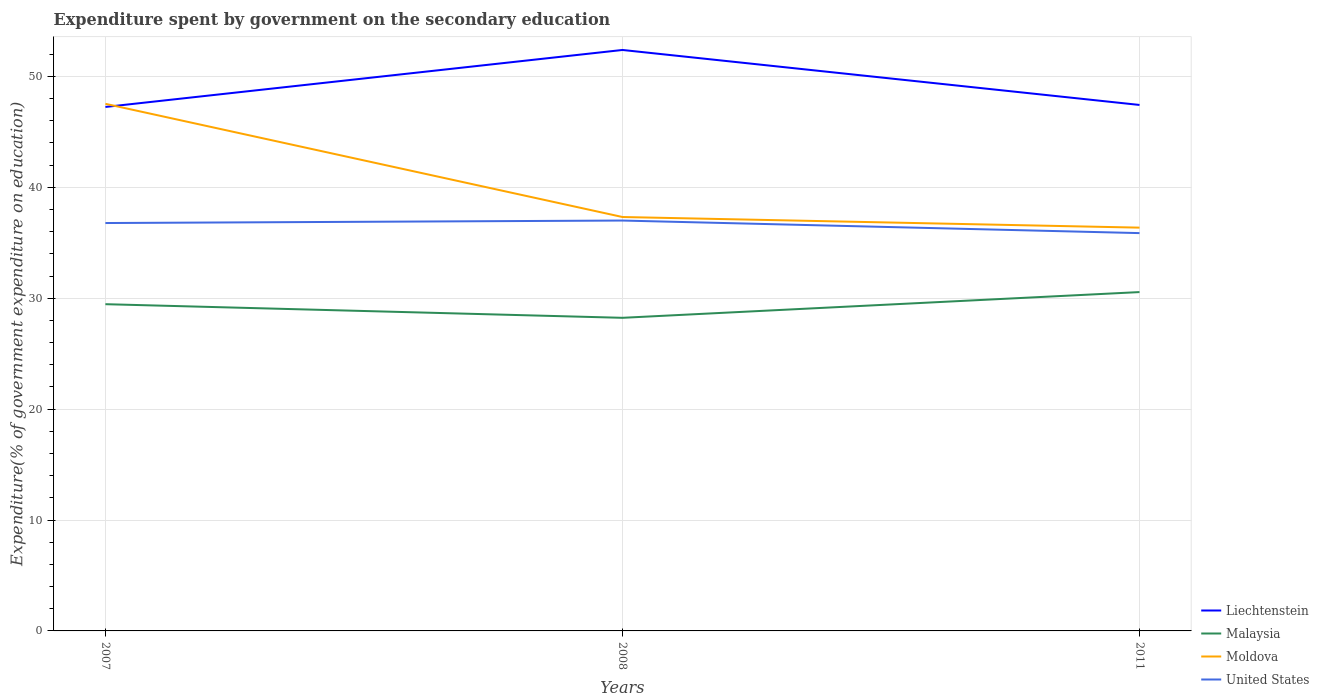Is the number of lines equal to the number of legend labels?
Your answer should be compact. Yes. Across all years, what is the maximum expenditure spent by government on the secondary education in Liechtenstein?
Give a very brief answer. 47.25. What is the total expenditure spent by government on the secondary education in Moldova in the graph?
Give a very brief answer. 10.21. What is the difference between the highest and the second highest expenditure spent by government on the secondary education in Liechtenstein?
Your answer should be very brief. 5.14. Are the values on the major ticks of Y-axis written in scientific E-notation?
Ensure brevity in your answer.  No. Does the graph contain any zero values?
Offer a very short reply. No. Does the graph contain grids?
Offer a very short reply. Yes. How are the legend labels stacked?
Offer a very short reply. Vertical. What is the title of the graph?
Provide a succinct answer. Expenditure spent by government on the secondary education. What is the label or title of the X-axis?
Offer a very short reply. Years. What is the label or title of the Y-axis?
Ensure brevity in your answer.  Expenditure(% of government expenditure on education). What is the Expenditure(% of government expenditure on education) in Liechtenstein in 2007?
Offer a terse response. 47.25. What is the Expenditure(% of government expenditure on education) of Malaysia in 2007?
Your response must be concise. 29.46. What is the Expenditure(% of government expenditure on education) of Moldova in 2007?
Your answer should be very brief. 47.53. What is the Expenditure(% of government expenditure on education) of United States in 2007?
Offer a terse response. 36.78. What is the Expenditure(% of government expenditure on education) of Liechtenstein in 2008?
Your answer should be very brief. 52.39. What is the Expenditure(% of government expenditure on education) in Malaysia in 2008?
Offer a terse response. 28.23. What is the Expenditure(% of government expenditure on education) of Moldova in 2008?
Keep it short and to the point. 37.32. What is the Expenditure(% of government expenditure on education) of United States in 2008?
Make the answer very short. 37. What is the Expenditure(% of government expenditure on education) in Liechtenstein in 2011?
Provide a succinct answer. 47.43. What is the Expenditure(% of government expenditure on education) of Malaysia in 2011?
Your answer should be compact. 30.55. What is the Expenditure(% of government expenditure on education) of Moldova in 2011?
Offer a terse response. 36.36. What is the Expenditure(% of government expenditure on education) in United States in 2011?
Offer a terse response. 35.87. Across all years, what is the maximum Expenditure(% of government expenditure on education) in Liechtenstein?
Offer a very short reply. 52.39. Across all years, what is the maximum Expenditure(% of government expenditure on education) in Malaysia?
Your answer should be compact. 30.55. Across all years, what is the maximum Expenditure(% of government expenditure on education) of Moldova?
Your answer should be compact. 47.53. Across all years, what is the maximum Expenditure(% of government expenditure on education) in United States?
Provide a succinct answer. 37. Across all years, what is the minimum Expenditure(% of government expenditure on education) in Liechtenstein?
Keep it short and to the point. 47.25. Across all years, what is the minimum Expenditure(% of government expenditure on education) in Malaysia?
Keep it short and to the point. 28.23. Across all years, what is the minimum Expenditure(% of government expenditure on education) in Moldova?
Ensure brevity in your answer.  36.36. Across all years, what is the minimum Expenditure(% of government expenditure on education) in United States?
Your response must be concise. 35.87. What is the total Expenditure(% of government expenditure on education) of Liechtenstein in the graph?
Your answer should be very brief. 147.06. What is the total Expenditure(% of government expenditure on education) in Malaysia in the graph?
Give a very brief answer. 88.25. What is the total Expenditure(% of government expenditure on education) of Moldova in the graph?
Your answer should be compact. 121.22. What is the total Expenditure(% of government expenditure on education) in United States in the graph?
Provide a succinct answer. 109.66. What is the difference between the Expenditure(% of government expenditure on education) of Liechtenstein in 2007 and that in 2008?
Your answer should be compact. -5.14. What is the difference between the Expenditure(% of government expenditure on education) of Malaysia in 2007 and that in 2008?
Your answer should be compact. 1.23. What is the difference between the Expenditure(% of government expenditure on education) of Moldova in 2007 and that in 2008?
Your response must be concise. 10.21. What is the difference between the Expenditure(% of government expenditure on education) in United States in 2007 and that in 2008?
Provide a short and direct response. -0.22. What is the difference between the Expenditure(% of government expenditure on education) of Liechtenstein in 2007 and that in 2011?
Your response must be concise. -0.18. What is the difference between the Expenditure(% of government expenditure on education) in Malaysia in 2007 and that in 2011?
Give a very brief answer. -1.09. What is the difference between the Expenditure(% of government expenditure on education) of Moldova in 2007 and that in 2011?
Your answer should be very brief. 11.16. What is the difference between the Expenditure(% of government expenditure on education) in United States in 2007 and that in 2011?
Make the answer very short. 0.91. What is the difference between the Expenditure(% of government expenditure on education) in Liechtenstein in 2008 and that in 2011?
Your answer should be compact. 4.96. What is the difference between the Expenditure(% of government expenditure on education) of Malaysia in 2008 and that in 2011?
Provide a short and direct response. -2.32. What is the difference between the Expenditure(% of government expenditure on education) in Moldova in 2008 and that in 2011?
Provide a short and direct response. 0.96. What is the difference between the Expenditure(% of government expenditure on education) in United States in 2008 and that in 2011?
Your response must be concise. 1.13. What is the difference between the Expenditure(% of government expenditure on education) in Liechtenstein in 2007 and the Expenditure(% of government expenditure on education) in Malaysia in 2008?
Provide a short and direct response. 19.01. What is the difference between the Expenditure(% of government expenditure on education) of Liechtenstein in 2007 and the Expenditure(% of government expenditure on education) of Moldova in 2008?
Offer a very short reply. 9.93. What is the difference between the Expenditure(% of government expenditure on education) of Liechtenstein in 2007 and the Expenditure(% of government expenditure on education) of United States in 2008?
Provide a short and direct response. 10.24. What is the difference between the Expenditure(% of government expenditure on education) in Malaysia in 2007 and the Expenditure(% of government expenditure on education) in Moldova in 2008?
Offer a terse response. -7.86. What is the difference between the Expenditure(% of government expenditure on education) of Malaysia in 2007 and the Expenditure(% of government expenditure on education) of United States in 2008?
Your answer should be very brief. -7.54. What is the difference between the Expenditure(% of government expenditure on education) of Moldova in 2007 and the Expenditure(% of government expenditure on education) of United States in 2008?
Provide a succinct answer. 10.52. What is the difference between the Expenditure(% of government expenditure on education) of Liechtenstein in 2007 and the Expenditure(% of government expenditure on education) of Malaysia in 2011?
Ensure brevity in your answer.  16.69. What is the difference between the Expenditure(% of government expenditure on education) of Liechtenstein in 2007 and the Expenditure(% of government expenditure on education) of Moldova in 2011?
Ensure brevity in your answer.  10.88. What is the difference between the Expenditure(% of government expenditure on education) in Liechtenstein in 2007 and the Expenditure(% of government expenditure on education) in United States in 2011?
Offer a very short reply. 11.38. What is the difference between the Expenditure(% of government expenditure on education) in Malaysia in 2007 and the Expenditure(% of government expenditure on education) in Moldova in 2011?
Your answer should be very brief. -6.9. What is the difference between the Expenditure(% of government expenditure on education) in Malaysia in 2007 and the Expenditure(% of government expenditure on education) in United States in 2011?
Your answer should be very brief. -6.41. What is the difference between the Expenditure(% of government expenditure on education) in Moldova in 2007 and the Expenditure(% of government expenditure on education) in United States in 2011?
Provide a short and direct response. 11.66. What is the difference between the Expenditure(% of government expenditure on education) in Liechtenstein in 2008 and the Expenditure(% of government expenditure on education) in Malaysia in 2011?
Your answer should be compact. 21.83. What is the difference between the Expenditure(% of government expenditure on education) of Liechtenstein in 2008 and the Expenditure(% of government expenditure on education) of Moldova in 2011?
Provide a short and direct response. 16.02. What is the difference between the Expenditure(% of government expenditure on education) of Liechtenstein in 2008 and the Expenditure(% of government expenditure on education) of United States in 2011?
Ensure brevity in your answer.  16.51. What is the difference between the Expenditure(% of government expenditure on education) of Malaysia in 2008 and the Expenditure(% of government expenditure on education) of Moldova in 2011?
Your answer should be compact. -8.13. What is the difference between the Expenditure(% of government expenditure on education) in Malaysia in 2008 and the Expenditure(% of government expenditure on education) in United States in 2011?
Offer a terse response. -7.64. What is the difference between the Expenditure(% of government expenditure on education) in Moldova in 2008 and the Expenditure(% of government expenditure on education) in United States in 2011?
Offer a terse response. 1.45. What is the average Expenditure(% of government expenditure on education) of Liechtenstein per year?
Provide a succinct answer. 49.02. What is the average Expenditure(% of government expenditure on education) in Malaysia per year?
Provide a succinct answer. 29.42. What is the average Expenditure(% of government expenditure on education) in Moldova per year?
Keep it short and to the point. 40.41. What is the average Expenditure(% of government expenditure on education) of United States per year?
Offer a very short reply. 36.55. In the year 2007, what is the difference between the Expenditure(% of government expenditure on education) in Liechtenstein and Expenditure(% of government expenditure on education) in Malaysia?
Your answer should be compact. 17.79. In the year 2007, what is the difference between the Expenditure(% of government expenditure on education) of Liechtenstein and Expenditure(% of government expenditure on education) of Moldova?
Offer a terse response. -0.28. In the year 2007, what is the difference between the Expenditure(% of government expenditure on education) of Liechtenstein and Expenditure(% of government expenditure on education) of United States?
Your answer should be compact. 10.47. In the year 2007, what is the difference between the Expenditure(% of government expenditure on education) in Malaysia and Expenditure(% of government expenditure on education) in Moldova?
Provide a short and direct response. -18.07. In the year 2007, what is the difference between the Expenditure(% of government expenditure on education) of Malaysia and Expenditure(% of government expenditure on education) of United States?
Make the answer very short. -7.32. In the year 2007, what is the difference between the Expenditure(% of government expenditure on education) in Moldova and Expenditure(% of government expenditure on education) in United States?
Your response must be concise. 10.75. In the year 2008, what is the difference between the Expenditure(% of government expenditure on education) of Liechtenstein and Expenditure(% of government expenditure on education) of Malaysia?
Offer a very short reply. 24.15. In the year 2008, what is the difference between the Expenditure(% of government expenditure on education) in Liechtenstein and Expenditure(% of government expenditure on education) in Moldova?
Keep it short and to the point. 15.06. In the year 2008, what is the difference between the Expenditure(% of government expenditure on education) of Liechtenstein and Expenditure(% of government expenditure on education) of United States?
Keep it short and to the point. 15.38. In the year 2008, what is the difference between the Expenditure(% of government expenditure on education) of Malaysia and Expenditure(% of government expenditure on education) of Moldova?
Make the answer very short. -9.09. In the year 2008, what is the difference between the Expenditure(% of government expenditure on education) in Malaysia and Expenditure(% of government expenditure on education) in United States?
Provide a short and direct response. -8.77. In the year 2008, what is the difference between the Expenditure(% of government expenditure on education) in Moldova and Expenditure(% of government expenditure on education) in United States?
Your answer should be very brief. 0.32. In the year 2011, what is the difference between the Expenditure(% of government expenditure on education) in Liechtenstein and Expenditure(% of government expenditure on education) in Malaysia?
Your answer should be compact. 16.87. In the year 2011, what is the difference between the Expenditure(% of government expenditure on education) of Liechtenstein and Expenditure(% of government expenditure on education) of Moldova?
Make the answer very short. 11.06. In the year 2011, what is the difference between the Expenditure(% of government expenditure on education) of Liechtenstein and Expenditure(% of government expenditure on education) of United States?
Give a very brief answer. 11.56. In the year 2011, what is the difference between the Expenditure(% of government expenditure on education) in Malaysia and Expenditure(% of government expenditure on education) in Moldova?
Make the answer very short. -5.81. In the year 2011, what is the difference between the Expenditure(% of government expenditure on education) of Malaysia and Expenditure(% of government expenditure on education) of United States?
Your answer should be very brief. -5.32. In the year 2011, what is the difference between the Expenditure(% of government expenditure on education) of Moldova and Expenditure(% of government expenditure on education) of United States?
Ensure brevity in your answer.  0.49. What is the ratio of the Expenditure(% of government expenditure on education) in Liechtenstein in 2007 to that in 2008?
Your answer should be compact. 0.9. What is the ratio of the Expenditure(% of government expenditure on education) of Malaysia in 2007 to that in 2008?
Make the answer very short. 1.04. What is the ratio of the Expenditure(% of government expenditure on education) in Moldova in 2007 to that in 2008?
Keep it short and to the point. 1.27. What is the ratio of the Expenditure(% of government expenditure on education) in United States in 2007 to that in 2008?
Provide a succinct answer. 0.99. What is the ratio of the Expenditure(% of government expenditure on education) in Liechtenstein in 2007 to that in 2011?
Offer a terse response. 1. What is the ratio of the Expenditure(% of government expenditure on education) of Moldova in 2007 to that in 2011?
Offer a terse response. 1.31. What is the ratio of the Expenditure(% of government expenditure on education) of United States in 2007 to that in 2011?
Your answer should be compact. 1.03. What is the ratio of the Expenditure(% of government expenditure on education) in Liechtenstein in 2008 to that in 2011?
Offer a terse response. 1.1. What is the ratio of the Expenditure(% of government expenditure on education) in Malaysia in 2008 to that in 2011?
Provide a succinct answer. 0.92. What is the ratio of the Expenditure(% of government expenditure on education) in Moldova in 2008 to that in 2011?
Give a very brief answer. 1.03. What is the ratio of the Expenditure(% of government expenditure on education) of United States in 2008 to that in 2011?
Give a very brief answer. 1.03. What is the difference between the highest and the second highest Expenditure(% of government expenditure on education) in Liechtenstein?
Provide a short and direct response. 4.96. What is the difference between the highest and the second highest Expenditure(% of government expenditure on education) in Malaysia?
Provide a succinct answer. 1.09. What is the difference between the highest and the second highest Expenditure(% of government expenditure on education) in Moldova?
Your answer should be compact. 10.21. What is the difference between the highest and the second highest Expenditure(% of government expenditure on education) of United States?
Your response must be concise. 0.22. What is the difference between the highest and the lowest Expenditure(% of government expenditure on education) in Liechtenstein?
Offer a very short reply. 5.14. What is the difference between the highest and the lowest Expenditure(% of government expenditure on education) in Malaysia?
Your answer should be compact. 2.32. What is the difference between the highest and the lowest Expenditure(% of government expenditure on education) in Moldova?
Your answer should be compact. 11.16. What is the difference between the highest and the lowest Expenditure(% of government expenditure on education) in United States?
Make the answer very short. 1.13. 